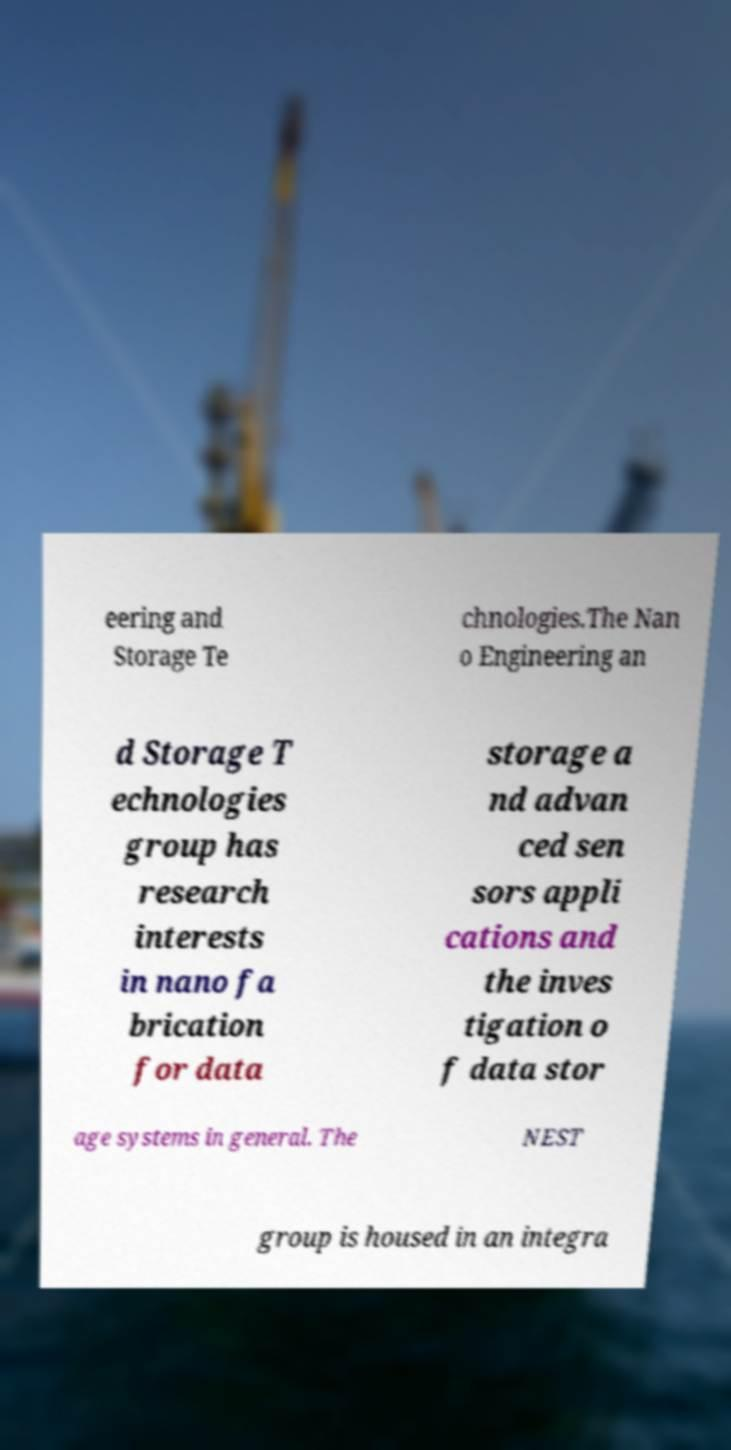Please read and relay the text visible in this image. What does it say? eering and Storage Te chnologies.The Nan o Engineering an d Storage T echnologies group has research interests in nano fa brication for data storage a nd advan ced sen sors appli cations and the inves tigation o f data stor age systems in general. The NEST group is housed in an integra 